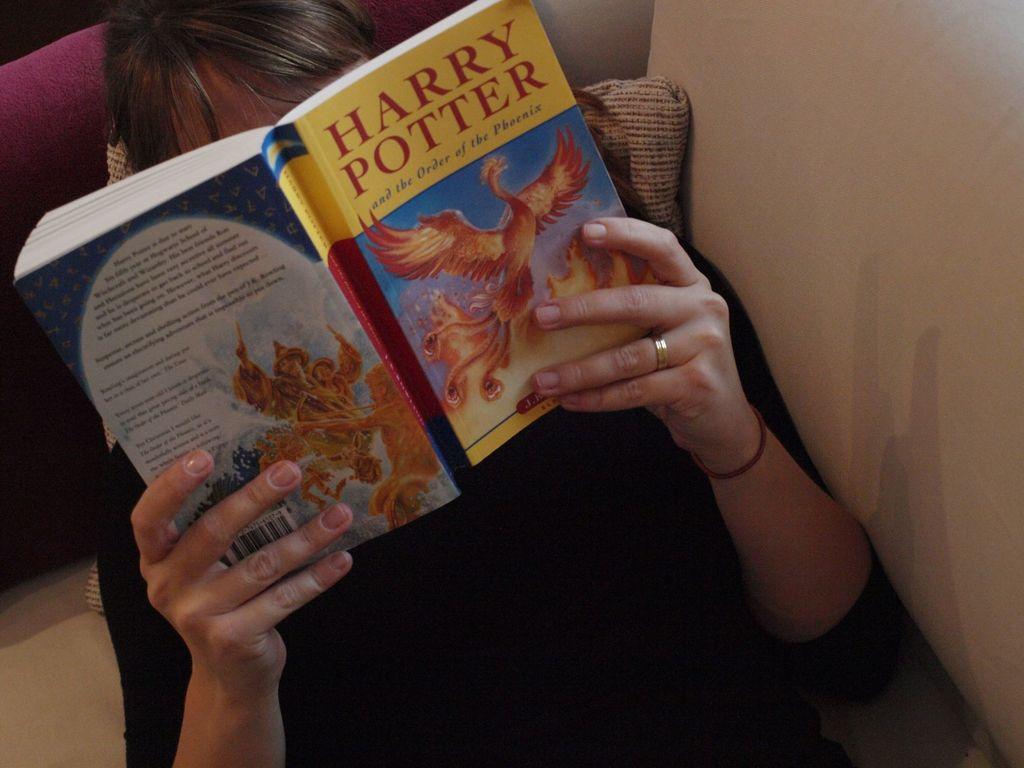What is the title of the book?
Your response must be concise. Harry potter. Which harry potter book is this?
Provide a short and direct response. The order of the phoenix. 